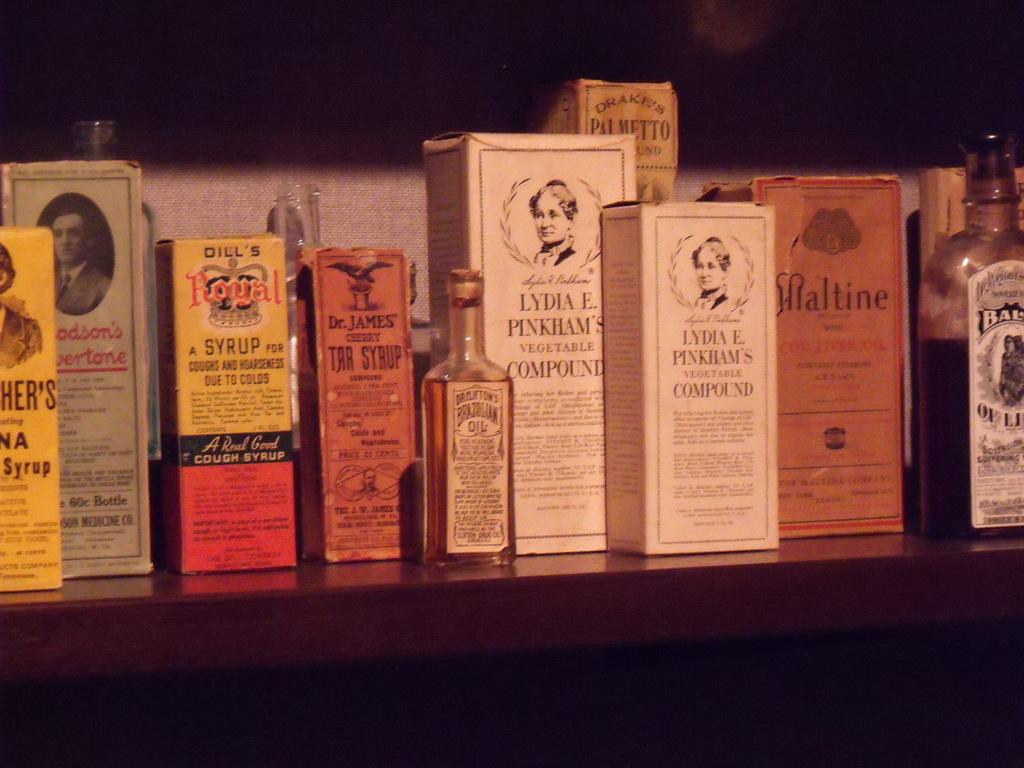What ailments is dill's royal syrup used for?
Provide a short and direct response. Coughs and hoarseness. Is there more than one type of medicine on the shelf?
Provide a short and direct response. Yes. 